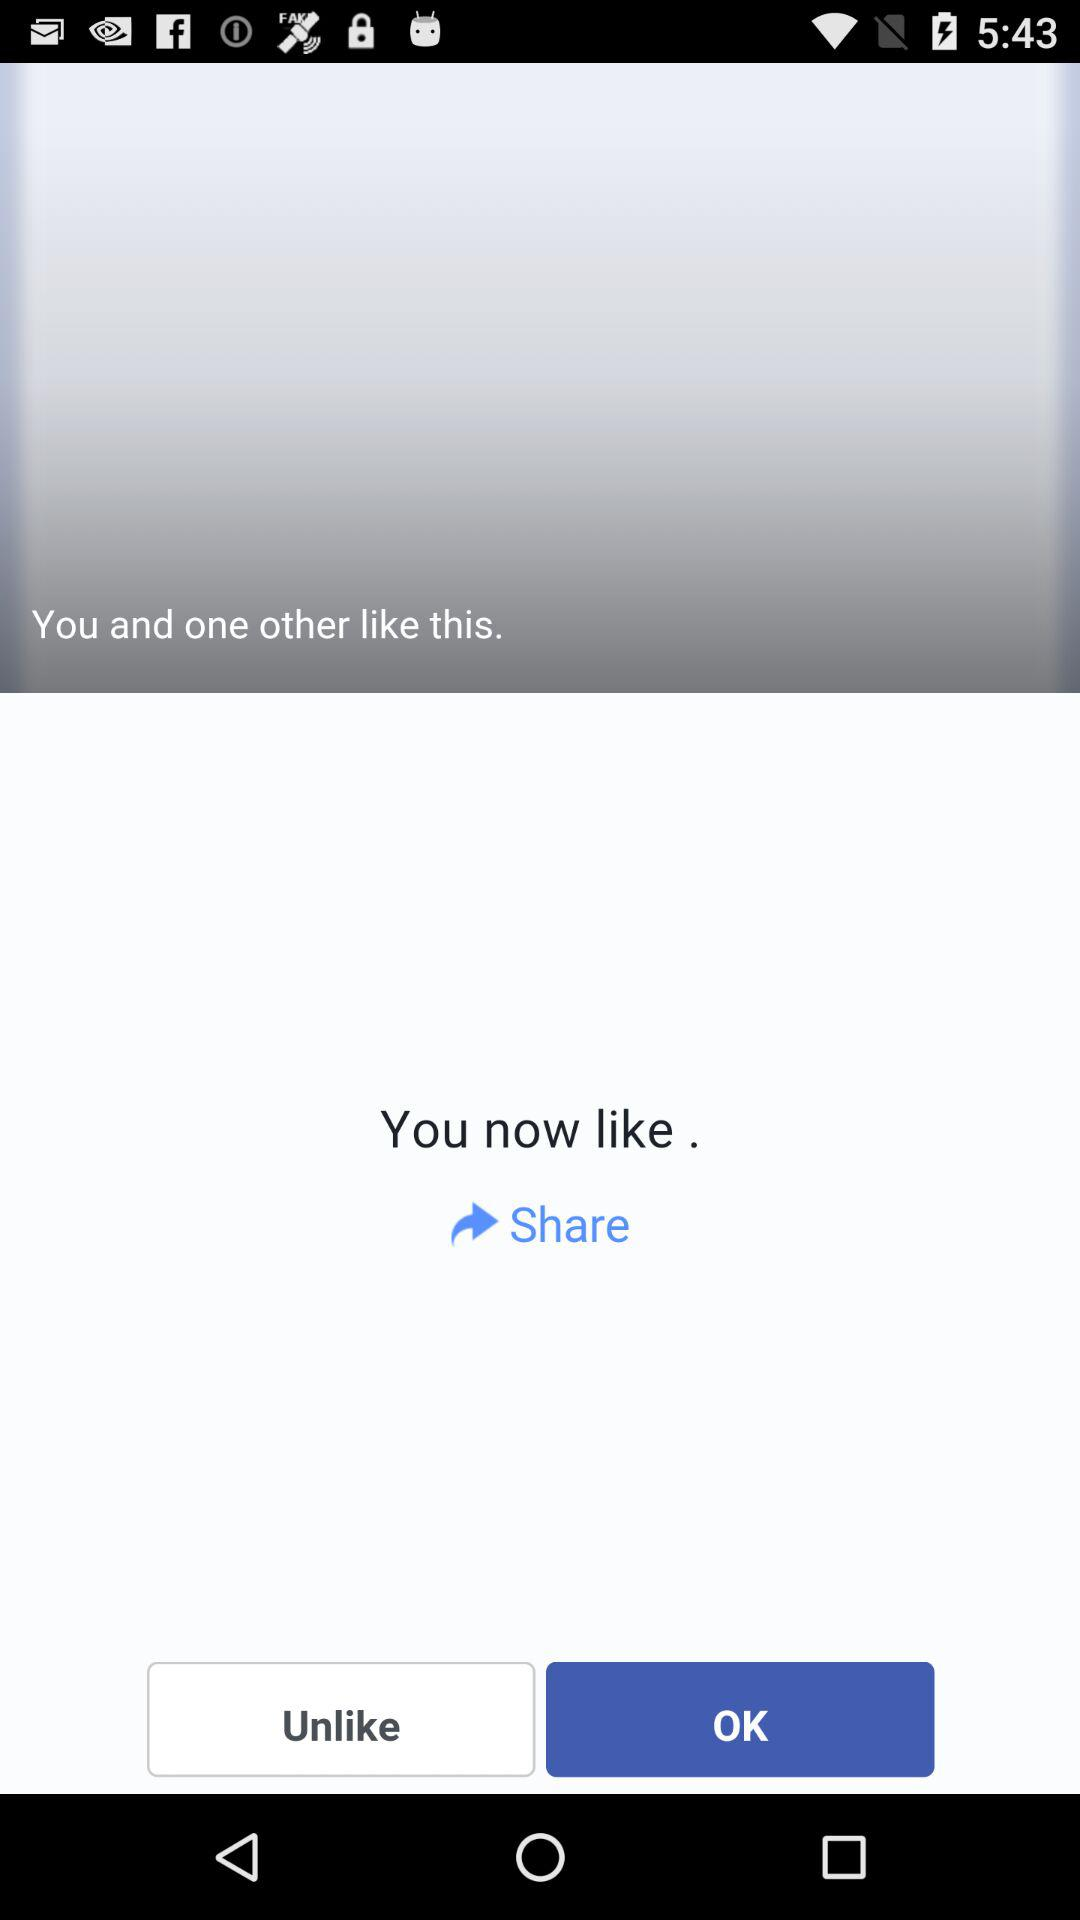How many people liked this post?
Answer the question using a single word or phrase. 2 